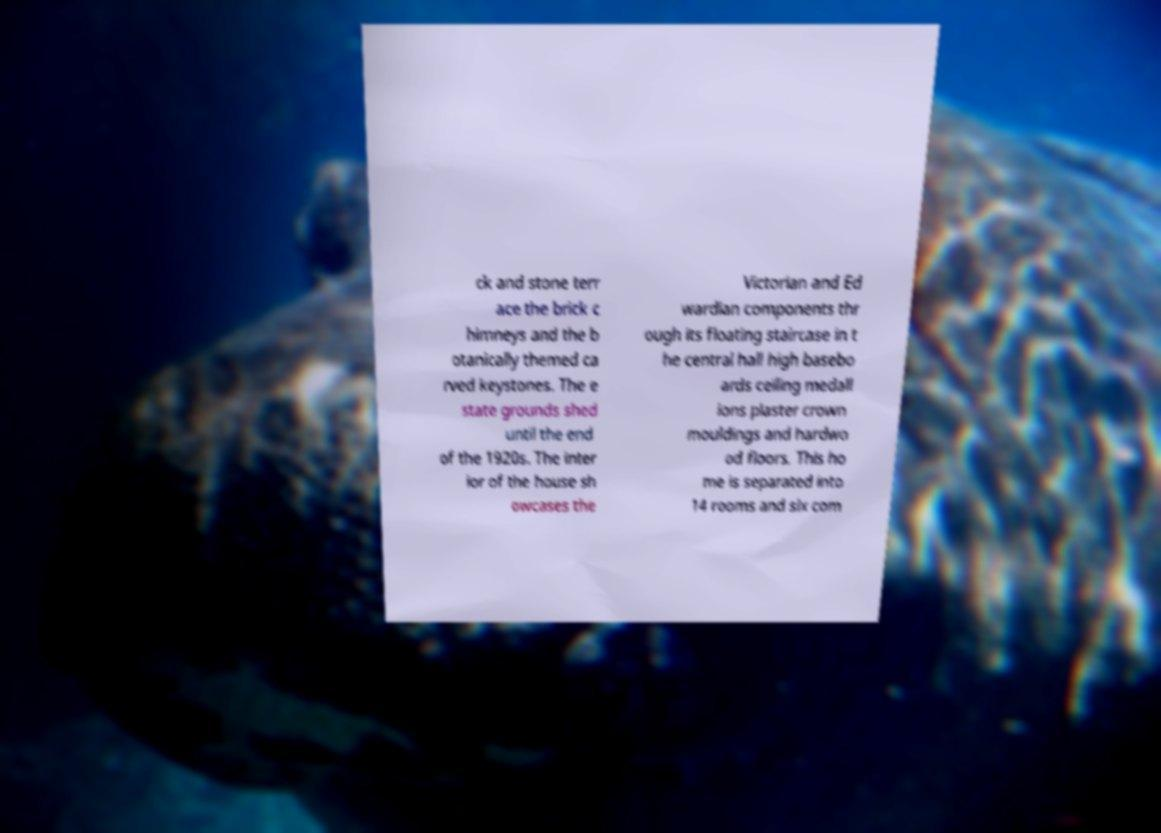Please read and relay the text visible in this image. What does it say? ck and stone terr ace the brick c himneys and the b otanically themed ca rved keystones. The e state grounds shed until the end of the 1920s. The inter ior of the house sh owcases the Victorian and Ed wardian components thr ough its floating staircase in t he central hall high basebo ards ceiling medall ions plaster crown mouldings and hardwo od floors. This ho me is separated into 14 rooms and six com 